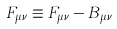Convert formula to latex. <formula><loc_0><loc_0><loc_500><loc_500>F _ { \mu \nu } \equiv F _ { \mu \nu } - B _ { \mu \nu }</formula> 